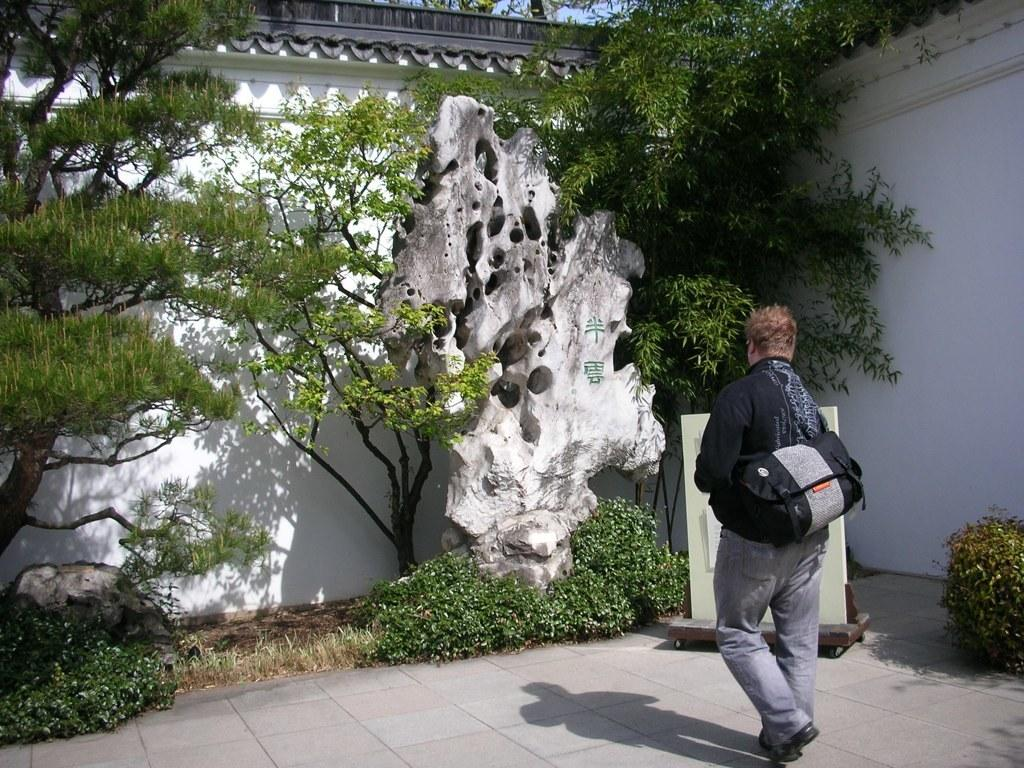Who is present in the image? There is a person in the image. What is the person holding? The person is holding a bag. What type of natural elements can be seen in the image? There are trees and plants in the image. What type of man-made structures are visible in the image? There are walls in the image. What type of yam is being used as a prop in the image? There is no yam present in the image. 